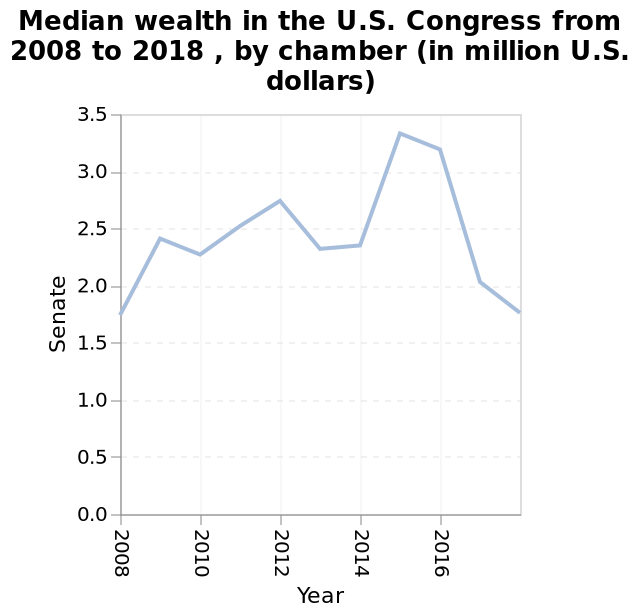<image>
please summary the statistics and relations of the chart From 2008 the median wealth of the Senate gradually rose until 2015 and thereafter it quite rapidly decreased until it was the same level in 2018 as it was in 2008. How is the x-axis scaled in the diagram?  The x-axis is scaled using a linear scale ranging from 2008 to 2016, representing the years. What happened to the median wealth of the Senate between 2008 and 2015?  The median wealth of the Senate gradually rose during this period. What happened to the median wealth of the Senate between 2015 and 2018?  The median wealth of the Senate quite rapidly decreased during this period. What is the maximum value plotted on the y-axis? The maximum value plotted on the y-axis is 3.5 million U.S. dollars. 